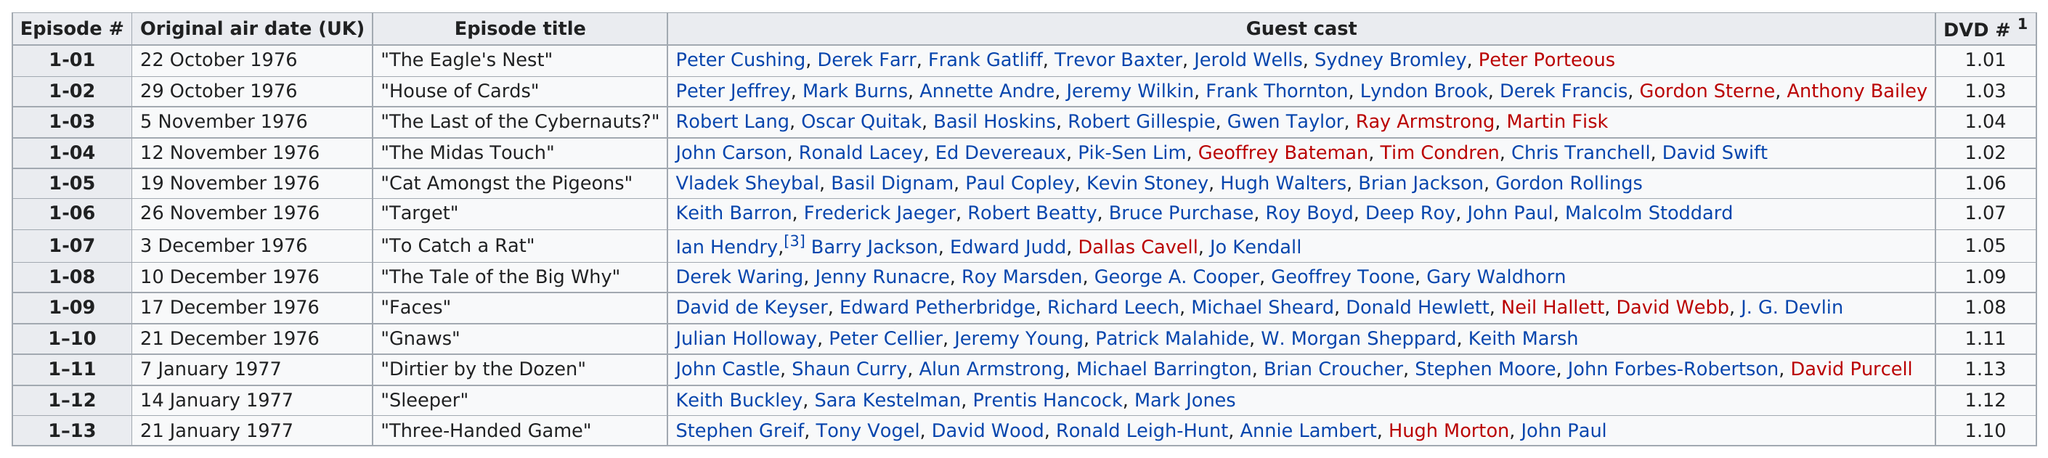List a handful of essential elements in this visual. The episode before "The Tale of the Big Why" is titled 'Faces'. What is the total number of episodes on the chart? There are 13 episodes in total. The least number of guest casts on an episode is four. The first episode of the television show "The Muppet Show" aired on October 22, 1976. The previous date to the day that episode 3 started is October 29th, 1976. 